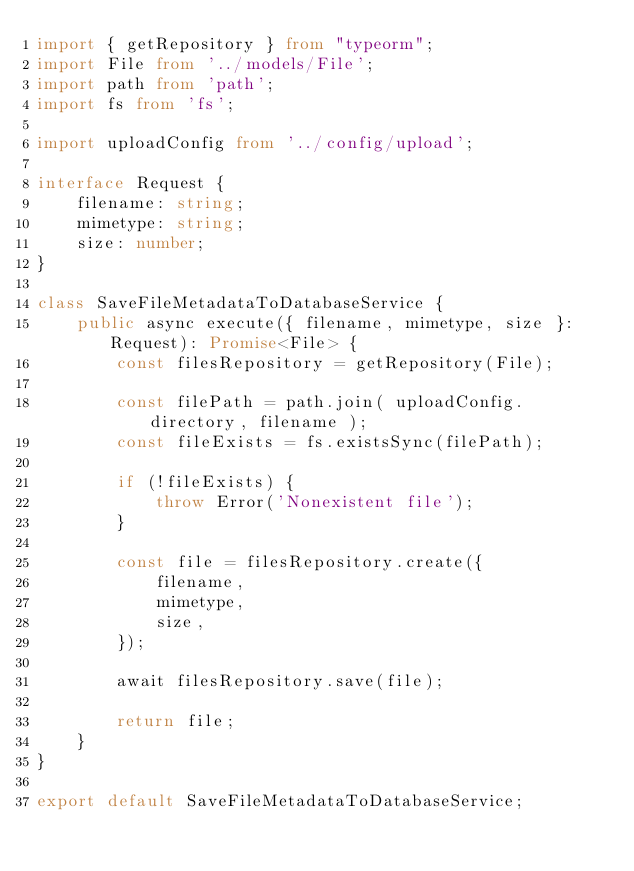Convert code to text. <code><loc_0><loc_0><loc_500><loc_500><_TypeScript_>import { getRepository } from "typeorm";
import File from '../models/File';
import path from 'path';
import fs from 'fs';

import uploadConfig from '../config/upload';

interface Request {
    filename: string;
    mimetype: string;
    size: number;
}

class SaveFileMetadataToDatabaseService {
    public async execute({ filename, mimetype, size }: Request): Promise<File> {
        const filesRepository = getRepository(File);

        const filePath = path.join( uploadConfig.directory, filename );
        const fileExists = fs.existsSync(filePath);

        if (!fileExists) {
            throw Error('Nonexistent file');
        }

        const file = filesRepository.create({
            filename,
            mimetype,
            size,
        });

        await filesRepository.save(file);

        return file;
    }
}

export default SaveFileMetadataToDatabaseService;</code> 